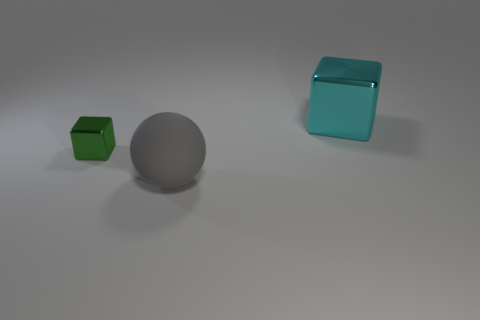Add 1 large spheres. How many objects exist? 4 Subtract all balls. How many objects are left? 2 Add 3 tiny yellow rubber cubes. How many tiny yellow rubber cubes exist? 3 Subtract 0 green spheres. How many objects are left? 3 Subtract all small blocks. Subtract all big objects. How many objects are left? 0 Add 2 large blocks. How many large blocks are left? 3 